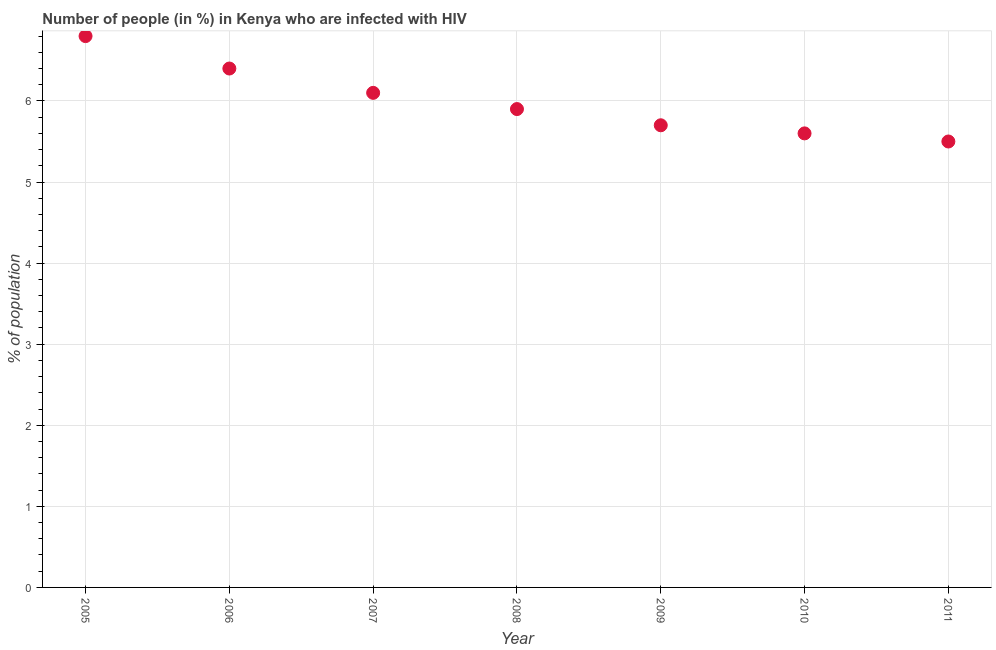What is the number of people infected with hiv in 2011?
Your response must be concise. 5.5. Across all years, what is the maximum number of people infected with hiv?
Give a very brief answer. 6.8. Across all years, what is the minimum number of people infected with hiv?
Your answer should be very brief. 5.5. What is the sum of the number of people infected with hiv?
Offer a terse response. 42. What is the difference between the number of people infected with hiv in 2005 and 2008?
Provide a succinct answer. 0.9. What is the average number of people infected with hiv per year?
Give a very brief answer. 6. What is the ratio of the number of people infected with hiv in 2005 to that in 2009?
Your answer should be very brief. 1.19. What is the difference between the highest and the second highest number of people infected with hiv?
Offer a terse response. 0.4. What is the difference between the highest and the lowest number of people infected with hiv?
Make the answer very short. 1.3. In how many years, is the number of people infected with hiv greater than the average number of people infected with hiv taken over all years?
Offer a very short reply. 3. Does the number of people infected with hiv monotonically increase over the years?
Ensure brevity in your answer.  No. How many dotlines are there?
Provide a succinct answer. 1. Are the values on the major ticks of Y-axis written in scientific E-notation?
Provide a short and direct response. No. What is the title of the graph?
Provide a succinct answer. Number of people (in %) in Kenya who are infected with HIV. What is the label or title of the Y-axis?
Give a very brief answer. % of population. What is the % of population in 2008?
Make the answer very short. 5.9. What is the % of population in 2010?
Give a very brief answer. 5.6. What is the % of population in 2011?
Offer a very short reply. 5.5. What is the difference between the % of population in 2005 and 2008?
Ensure brevity in your answer.  0.9. What is the difference between the % of population in 2005 and 2010?
Ensure brevity in your answer.  1.2. What is the difference between the % of population in 2006 and 2007?
Make the answer very short. 0.3. What is the difference between the % of population in 2006 and 2009?
Offer a very short reply. 0.7. What is the difference between the % of population in 2006 and 2010?
Give a very brief answer. 0.8. What is the difference between the % of population in 2007 and 2008?
Provide a short and direct response. 0.2. What is the difference between the % of population in 2007 and 2010?
Ensure brevity in your answer.  0.5. What is the difference between the % of population in 2007 and 2011?
Ensure brevity in your answer.  0.6. What is the difference between the % of population in 2008 and 2010?
Offer a very short reply. 0.3. What is the difference between the % of population in 2008 and 2011?
Offer a terse response. 0.4. What is the difference between the % of population in 2009 and 2010?
Keep it short and to the point. 0.1. What is the difference between the % of population in 2009 and 2011?
Give a very brief answer. 0.2. What is the ratio of the % of population in 2005 to that in 2006?
Ensure brevity in your answer.  1.06. What is the ratio of the % of population in 2005 to that in 2007?
Offer a terse response. 1.11. What is the ratio of the % of population in 2005 to that in 2008?
Keep it short and to the point. 1.15. What is the ratio of the % of population in 2005 to that in 2009?
Provide a succinct answer. 1.19. What is the ratio of the % of population in 2005 to that in 2010?
Give a very brief answer. 1.21. What is the ratio of the % of population in 2005 to that in 2011?
Offer a terse response. 1.24. What is the ratio of the % of population in 2006 to that in 2007?
Offer a very short reply. 1.05. What is the ratio of the % of population in 2006 to that in 2008?
Your response must be concise. 1.08. What is the ratio of the % of population in 2006 to that in 2009?
Offer a very short reply. 1.12. What is the ratio of the % of population in 2006 to that in 2010?
Provide a succinct answer. 1.14. What is the ratio of the % of population in 2006 to that in 2011?
Your answer should be compact. 1.16. What is the ratio of the % of population in 2007 to that in 2008?
Offer a terse response. 1.03. What is the ratio of the % of population in 2007 to that in 2009?
Offer a terse response. 1.07. What is the ratio of the % of population in 2007 to that in 2010?
Give a very brief answer. 1.09. What is the ratio of the % of population in 2007 to that in 2011?
Your answer should be compact. 1.11. What is the ratio of the % of population in 2008 to that in 2009?
Offer a very short reply. 1.03. What is the ratio of the % of population in 2008 to that in 2010?
Your answer should be compact. 1.05. What is the ratio of the % of population in 2008 to that in 2011?
Provide a short and direct response. 1.07. What is the ratio of the % of population in 2009 to that in 2011?
Offer a very short reply. 1.04. What is the ratio of the % of population in 2010 to that in 2011?
Keep it short and to the point. 1.02. 